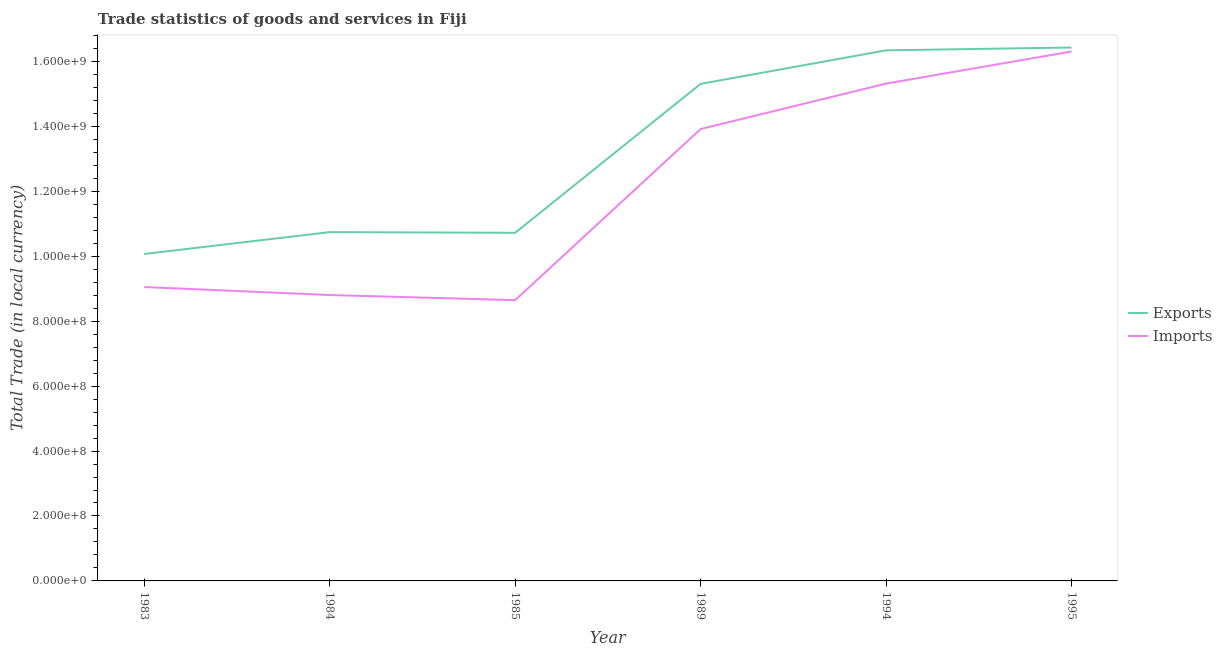How many different coloured lines are there?
Provide a succinct answer. 2. Does the line corresponding to imports of goods and services intersect with the line corresponding to export of goods and services?
Offer a very short reply. No. What is the imports of goods and services in 1989?
Your answer should be compact. 1.39e+09. Across all years, what is the maximum export of goods and services?
Offer a very short reply. 1.64e+09. Across all years, what is the minimum export of goods and services?
Offer a terse response. 1.01e+09. In which year was the imports of goods and services maximum?
Provide a succinct answer. 1995. In which year was the export of goods and services minimum?
Keep it short and to the point. 1983. What is the total export of goods and services in the graph?
Provide a short and direct response. 7.96e+09. What is the difference between the imports of goods and services in 1994 and that in 1995?
Give a very brief answer. -9.89e+07. What is the difference between the imports of goods and services in 1989 and the export of goods and services in 1994?
Your answer should be very brief. -2.42e+08. What is the average export of goods and services per year?
Provide a succinct answer. 1.33e+09. In the year 1983, what is the difference between the export of goods and services and imports of goods and services?
Offer a very short reply. 1.02e+08. In how many years, is the export of goods and services greater than 1200000000 LCU?
Keep it short and to the point. 3. What is the ratio of the export of goods and services in 1983 to that in 1989?
Your response must be concise. 0.66. Is the export of goods and services in 1983 less than that in 1985?
Keep it short and to the point. Yes. What is the difference between the highest and the second highest export of goods and services?
Your response must be concise. 8.73e+06. What is the difference between the highest and the lowest export of goods and services?
Ensure brevity in your answer.  6.36e+08. Is the sum of the export of goods and services in 1984 and 1994 greater than the maximum imports of goods and services across all years?
Offer a very short reply. Yes. Does the export of goods and services monotonically increase over the years?
Your answer should be very brief. No. Is the imports of goods and services strictly greater than the export of goods and services over the years?
Provide a short and direct response. No. What is the difference between two consecutive major ticks on the Y-axis?
Your response must be concise. 2.00e+08. Are the values on the major ticks of Y-axis written in scientific E-notation?
Make the answer very short. Yes. Does the graph contain any zero values?
Provide a short and direct response. No. Where does the legend appear in the graph?
Your answer should be compact. Center right. What is the title of the graph?
Your answer should be very brief. Trade statistics of goods and services in Fiji. Does "Rural" appear as one of the legend labels in the graph?
Ensure brevity in your answer.  No. What is the label or title of the X-axis?
Ensure brevity in your answer.  Year. What is the label or title of the Y-axis?
Provide a short and direct response. Total Trade (in local currency). What is the Total Trade (in local currency) of Exports in 1983?
Offer a terse response. 1.01e+09. What is the Total Trade (in local currency) of Imports in 1983?
Make the answer very short. 9.05e+08. What is the Total Trade (in local currency) of Exports in 1984?
Your answer should be very brief. 1.07e+09. What is the Total Trade (in local currency) of Imports in 1984?
Offer a very short reply. 8.81e+08. What is the Total Trade (in local currency) of Exports in 1985?
Make the answer very short. 1.07e+09. What is the Total Trade (in local currency) of Imports in 1985?
Your response must be concise. 8.65e+08. What is the Total Trade (in local currency) in Exports in 1989?
Your response must be concise. 1.53e+09. What is the Total Trade (in local currency) of Imports in 1989?
Your response must be concise. 1.39e+09. What is the Total Trade (in local currency) in Exports in 1994?
Offer a terse response. 1.63e+09. What is the Total Trade (in local currency) of Imports in 1994?
Give a very brief answer. 1.53e+09. What is the Total Trade (in local currency) in Exports in 1995?
Your answer should be compact. 1.64e+09. What is the Total Trade (in local currency) in Imports in 1995?
Give a very brief answer. 1.63e+09. Across all years, what is the maximum Total Trade (in local currency) in Exports?
Your response must be concise. 1.64e+09. Across all years, what is the maximum Total Trade (in local currency) of Imports?
Ensure brevity in your answer.  1.63e+09. Across all years, what is the minimum Total Trade (in local currency) in Exports?
Your answer should be very brief. 1.01e+09. Across all years, what is the minimum Total Trade (in local currency) in Imports?
Offer a very short reply. 8.65e+08. What is the total Total Trade (in local currency) in Exports in the graph?
Ensure brevity in your answer.  7.96e+09. What is the total Total Trade (in local currency) in Imports in the graph?
Your answer should be compact. 7.20e+09. What is the difference between the Total Trade (in local currency) in Exports in 1983 and that in 1984?
Offer a very short reply. -6.74e+07. What is the difference between the Total Trade (in local currency) of Imports in 1983 and that in 1984?
Ensure brevity in your answer.  2.47e+07. What is the difference between the Total Trade (in local currency) of Exports in 1983 and that in 1985?
Provide a short and direct response. -6.53e+07. What is the difference between the Total Trade (in local currency) in Imports in 1983 and that in 1985?
Ensure brevity in your answer.  4.04e+07. What is the difference between the Total Trade (in local currency) in Exports in 1983 and that in 1989?
Keep it short and to the point. -5.24e+08. What is the difference between the Total Trade (in local currency) in Imports in 1983 and that in 1989?
Your answer should be very brief. -4.87e+08. What is the difference between the Total Trade (in local currency) in Exports in 1983 and that in 1994?
Keep it short and to the point. -6.27e+08. What is the difference between the Total Trade (in local currency) of Imports in 1983 and that in 1994?
Make the answer very short. -6.27e+08. What is the difference between the Total Trade (in local currency) of Exports in 1983 and that in 1995?
Provide a succinct answer. -6.36e+08. What is the difference between the Total Trade (in local currency) in Imports in 1983 and that in 1995?
Provide a succinct answer. -7.25e+08. What is the difference between the Total Trade (in local currency) of Exports in 1984 and that in 1985?
Provide a succinct answer. 2.13e+06. What is the difference between the Total Trade (in local currency) in Imports in 1984 and that in 1985?
Offer a very short reply. 1.58e+07. What is the difference between the Total Trade (in local currency) of Exports in 1984 and that in 1989?
Provide a short and direct response. -4.57e+08. What is the difference between the Total Trade (in local currency) of Imports in 1984 and that in 1989?
Your answer should be compact. -5.11e+08. What is the difference between the Total Trade (in local currency) in Exports in 1984 and that in 1994?
Your answer should be compact. -5.60e+08. What is the difference between the Total Trade (in local currency) of Imports in 1984 and that in 1994?
Keep it short and to the point. -6.51e+08. What is the difference between the Total Trade (in local currency) of Exports in 1984 and that in 1995?
Ensure brevity in your answer.  -5.69e+08. What is the difference between the Total Trade (in local currency) in Imports in 1984 and that in 1995?
Your response must be concise. -7.50e+08. What is the difference between the Total Trade (in local currency) of Exports in 1985 and that in 1989?
Keep it short and to the point. -4.59e+08. What is the difference between the Total Trade (in local currency) in Imports in 1985 and that in 1989?
Provide a short and direct response. -5.27e+08. What is the difference between the Total Trade (in local currency) of Exports in 1985 and that in 1994?
Your answer should be very brief. -5.62e+08. What is the difference between the Total Trade (in local currency) in Imports in 1985 and that in 1994?
Offer a terse response. -6.67e+08. What is the difference between the Total Trade (in local currency) in Exports in 1985 and that in 1995?
Ensure brevity in your answer.  -5.71e+08. What is the difference between the Total Trade (in local currency) in Imports in 1985 and that in 1995?
Your answer should be very brief. -7.66e+08. What is the difference between the Total Trade (in local currency) in Exports in 1989 and that in 1994?
Offer a terse response. -1.03e+08. What is the difference between the Total Trade (in local currency) in Imports in 1989 and that in 1994?
Provide a short and direct response. -1.40e+08. What is the difference between the Total Trade (in local currency) in Exports in 1989 and that in 1995?
Your response must be concise. -1.12e+08. What is the difference between the Total Trade (in local currency) in Imports in 1989 and that in 1995?
Ensure brevity in your answer.  -2.39e+08. What is the difference between the Total Trade (in local currency) of Exports in 1994 and that in 1995?
Offer a terse response. -8.73e+06. What is the difference between the Total Trade (in local currency) of Imports in 1994 and that in 1995?
Provide a short and direct response. -9.89e+07. What is the difference between the Total Trade (in local currency) of Exports in 1983 and the Total Trade (in local currency) of Imports in 1984?
Your answer should be very brief. 1.26e+08. What is the difference between the Total Trade (in local currency) in Exports in 1983 and the Total Trade (in local currency) in Imports in 1985?
Provide a short and direct response. 1.42e+08. What is the difference between the Total Trade (in local currency) of Exports in 1983 and the Total Trade (in local currency) of Imports in 1989?
Provide a succinct answer. -3.85e+08. What is the difference between the Total Trade (in local currency) in Exports in 1983 and the Total Trade (in local currency) in Imports in 1994?
Offer a terse response. -5.25e+08. What is the difference between the Total Trade (in local currency) in Exports in 1983 and the Total Trade (in local currency) in Imports in 1995?
Offer a very short reply. -6.24e+08. What is the difference between the Total Trade (in local currency) in Exports in 1984 and the Total Trade (in local currency) in Imports in 1985?
Provide a succinct answer. 2.10e+08. What is the difference between the Total Trade (in local currency) of Exports in 1984 and the Total Trade (in local currency) of Imports in 1989?
Your answer should be compact. -3.17e+08. What is the difference between the Total Trade (in local currency) in Exports in 1984 and the Total Trade (in local currency) in Imports in 1994?
Provide a short and direct response. -4.57e+08. What is the difference between the Total Trade (in local currency) in Exports in 1984 and the Total Trade (in local currency) in Imports in 1995?
Provide a short and direct response. -5.56e+08. What is the difference between the Total Trade (in local currency) of Exports in 1985 and the Total Trade (in local currency) of Imports in 1989?
Keep it short and to the point. -3.19e+08. What is the difference between the Total Trade (in local currency) in Exports in 1985 and the Total Trade (in local currency) in Imports in 1994?
Provide a succinct answer. -4.60e+08. What is the difference between the Total Trade (in local currency) in Exports in 1985 and the Total Trade (in local currency) in Imports in 1995?
Keep it short and to the point. -5.58e+08. What is the difference between the Total Trade (in local currency) in Exports in 1989 and the Total Trade (in local currency) in Imports in 1994?
Offer a terse response. -8.19e+05. What is the difference between the Total Trade (in local currency) in Exports in 1989 and the Total Trade (in local currency) in Imports in 1995?
Provide a succinct answer. -9.97e+07. What is the difference between the Total Trade (in local currency) in Exports in 1994 and the Total Trade (in local currency) in Imports in 1995?
Offer a very short reply. 3.57e+06. What is the average Total Trade (in local currency) of Exports per year?
Keep it short and to the point. 1.33e+09. What is the average Total Trade (in local currency) in Imports per year?
Offer a terse response. 1.20e+09. In the year 1983, what is the difference between the Total Trade (in local currency) of Exports and Total Trade (in local currency) of Imports?
Provide a succinct answer. 1.02e+08. In the year 1984, what is the difference between the Total Trade (in local currency) in Exports and Total Trade (in local currency) in Imports?
Your answer should be very brief. 1.94e+08. In the year 1985, what is the difference between the Total Trade (in local currency) in Exports and Total Trade (in local currency) in Imports?
Offer a very short reply. 2.07e+08. In the year 1989, what is the difference between the Total Trade (in local currency) in Exports and Total Trade (in local currency) in Imports?
Give a very brief answer. 1.39e+08. In the year 1994, what is the difference between the Total Trade (in local currency) in Exports and Total Trade (in local currency) in Imports?
Offer a very short reply. 1.02e+08. In the year 1995, what is the difference between the Total Trade (in local currency) in Exports and Total Trade (in local currency) in Imports?
Offer a very short reply. 1.23e+07. What is the ratio of the Total Trade (in local currency) in Exports in 1983 to that in 1984?
Provide a short and direct response. 0.94. What is the ratio of the Total Trade (in local currency) of Imports in 1983 to that in 1984?
Your answer should be very brief. 1.03. What is the ratio of the Total Trade (in local currency) of Exports in 1983 to that in 1985?
Your response must be concise. 0.94. What is the ratio of the Total Trade (in local currency) of Imports in 1983 to that in 1985?
Your response must be concise. 1.05. What is the ratio of the Total Trade (in local currency) in Exports in 1983 to that in 1989?
Give a very brief answer. 0.66. What is the ratio of the Total Trade (in local currency) in Imports in 1983 to that in 1989?
Your answer should be compact. 0.65. What is the ratio of the Total Trade (in local currency) in Exports in 1983 to that in 1994?
Keep it short and to the point. 0.62. What is the ratio of the Total Trade (in local currency) of Imports in 1983 to that in 1994?
Keep it short and to the point. 0.59. What is the ratio of the Total Trade (in local currency) in Exports in 1983 to that in 1995?
Provide a succinct answer. 0.61. What is the ratio of the Total Trade (in local currency) in Imports in 1983 to that in 1995?
Give a very brief answer. 0.56. What is the ratio of the Total Trade (in local currency) in Exports in 1984 to that in 1985?
Give a very brief answer. 1. What is the ratio of the Total Trade (in local currency) of Imports in 1984 to that in 1985?
Give a very brief answer. 1.02. What is the ratio of the Total Trade (in local currency) of Exports in 1984 to that in 1989?
Make the answer very short. 0.7. What is the ratio of the Total Trade (in local currency) in Imports in 1984 to that in 1989?
Provide a short and direct response. 0.63. What is the ratio of the Total Trade (in local currency) in Exports in 1984 to that in 1994?
Offer a terse response. 0.66. What is the ratio of the Total Trade (in local currency) in Imports in 1984 to that in 1994?
Your answer should be compact. 0.57. What is the ratio of the Total Trade (in local currency) in Exports in 1984 to that in 1995?
Offer a very short reply. 0.65. What is the ratio of the Total Trade (in local currency) of Imports in 1984 to that in 1995?
Your answer should be compact. 0.54. What is the ratio of the Total Trade (in local currency) of Exports in 1985 to that in 1989?
Offer a very short reply. 0.7. What is the ratio of the Total Trade (in local currency) in Imports in 1985 to that in 1989?
Make the answer very short. 0.62. What is the ratio of the Total Trade (in local currency) of Exports in 1985 to that in 1994?
Provide a succinct answer. 0.66. What is the ratio of the Total Trade (in local currency) of Imports in 1985 to that in 1994?
Give a very brief answer. 0.56. What is the ratio of the Total Trade (in local currency) in Exports in 1985 to that in 1995?
Give a very brief answer. 0.65. What is the ratio of the Total Trade (in local currency) in Imports in 1985 to that in 1995?
Your response must be concise. 0.53. What is the ratio of the Total Trade (in local currency) in Exports in 1989 to that in 1994?
Ensure brevity in your answer.  0.94. What is the ratio of the Total Trade (in local currency) of Imports in 1989 to that in 1994?
Provide a short and direct response. 0.91. What is the ratio of the Total Trade (in local currency) of Exports in 1989 to that in 1995?
Offer a terse response. 0.93. What is the ratio of the Total Trade (in local currency) of Imports in 1989 to that in 1995?
Offer a very short reply. 0.85. What is the ratio of the Total Trade (in local currency) of Exports in 1994 to that in 1995?
Provide a succinct answer. 0.99. What is the ratio of the Total Trade (in local currency) in Imports in 1994 to that in 1995?
Give a very brief answer. 0.94. What is the difference between the highest and the second highest Total Trade (in local currency) in Exports?
Your response must be concise. 8.73e+06. What is the difference between the highest and the second highest Total Trade (in local currency) in Imports?
Provide a short and direct response. 9.89e+07. What is the difference between the highest and the lowest Total Trade (in local currency) of Exports?
Make the answer very short. 6.36e+08. What is the difference between the highest and the lowest Total Trade (in local currency) of Imports?
Provide a short and direct response. 7.66e+08. 